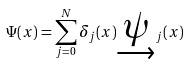<formula> <loc_0><loc_0><loc_500><loc_500>\Psi ( x ) = \sum _ { j = 0 } ^ { N } \delta _ { j } ( x ) \underrightarrow { \psi } _ { j } ( x )</formula> 